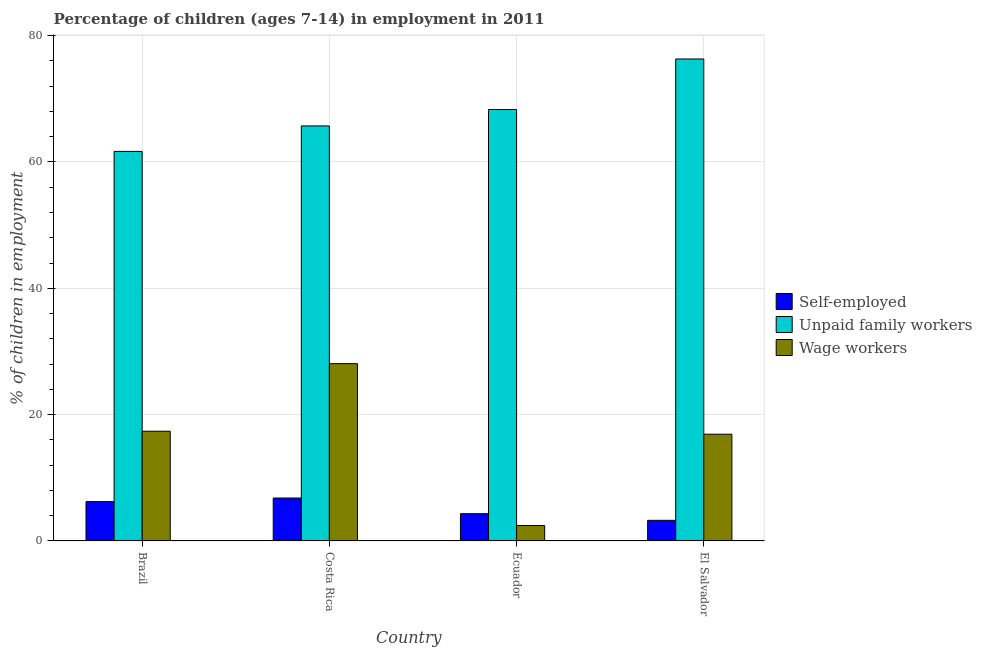How many different coloured bars are there?
Provide a short and direct response. 3. How many bars are there on the 1st tick from the left?
Give a very brief answer. 3. How many bars are there on the 2nd tick from the right?
Your answer should be compact. 3. What is the label of the 4th group of bars from the left?
Keep it short and to the point. El Salvador. In how many cases, is the number of bars for a given country not equal to the number of legend labels?
Give a very brief answer. 0. What is the percentage of children employed as unpaid family workers in Brazil?
Offer a very short reply. 61.67. Across all countries, what is the maximum percentage of children employed as unpaid family workers?
Your response must be concise. 76.3. Across all countries, what is the minimum percentage of children employed as unpaid family workers?
Your answer should be compact. 61.67. In which country was the percentage of children employed as wage workers maximum?
Give a very brief answer. Costa Rica. In which country was the percentage of children employed as unpaid family workers minimum?
Keep it short and to the point. Brazil. What is the total percentage of children employed as wage workers in the graph?
Your response must be concise. 64.79. What is the difference between the percentage of children employed as unpaid family workers in Brazil and that in Ecuador?
Your response must be concise. -6.63. What is the difference between the percentage of self employed children in Brazil and the percentage of children employed as unpaid family workers in Costa Rica?
Make the answer very short. -59.47. What is the average percentage of self employed children per country?
Your answer should be compact. 5.16. What is the difference between the percentage of self employed children and percentage of children employed as wage workers in Brazil?
Provide a succinct answer. -11.14. In how many countries, is the percentage of self employed children greater than 32 %?
Offer a very short reply. 0. What is the ratio of the percentage of self employed children in Brazil to that in Costa Rica?
Provide a short and direct response. 0.92. Is the difference between the percentage of self employed children in Costa Rica and Ecuador greater than the difference between the percentage of children employed as unpaid family workers in Costa Rica and Ecuador?
Provide a succinct answer. Yes. What is the difference between the highest and the lowest percentage of children employed as wage workers?
Your answer should be very brief. 25.62. In how many countries, is the percentage of children employed as wage workers greater than the average percentage of children employed as wage workers taken over all countries?
Offer a very short reply. 3. Is the sum of the percentage of self employed children in Costa Rica and Ecuador greater than the maximum percentage of children employed as wage workers across all countries?
Provide a succinct answer. No. What does the 2nd bar from the left in Ecuador represents?
Give a very brief answer. Unpaid family workers. What does the 1st bar from the right in Costa Rica represents?
Give a very brief answer. Wage workers. How many legend labels are there?
Offer a terse response. 3. How are the legend labels stacked?
Give a very brief answer. Vertical. What is the title of the graph?
Make the answer very short. Percentage of children (ages 7-14) in employment in 2011. Does "Argument" appear as one of the legend labels in the graph?
Make the answer very short. No. What is the label or title of the X-axis?
Ensure brevity in your answer.  Country. What is the label or title of the Y-axis?
Provide a succinct answer. % of children in employment. What is the % of children in employment of Self-employed in Brazil?
Ensure brevity in your answer.  6.23. What is the % of children in employment of Unpaid family workers in Brazil?
Offer a terse response. 61.67. What is the % of children in employment of Wage workers in Brazil?
Offer a terse response. 17.37. What is the % of children in employment of Self-employed in Costa Rica?
Your answer should be very brief. 6.8. What is the % of children in employment of Unpaid family workers in Costa Rica?
Offer a very short reply. 65.7. What is the % of children in employment of Wage workers in Costa Rica?
Provide a succinct answer. 28.07. What is the % of children in employment in Self-employed in Ecuador?
Keep it short and to the point. 4.32. What is the % of children in employment of Unpaid family workers in Ecuador?
Keep it short and to the point. 68.3. What is the % of children in employment in Wage workers in Ecuador?
Make the answer very short. 2.45. What is the % of children in employment of Self-employed in El Salvador?
Provide a short and direct response. 3.27. What is the % of children in employment in Unpaid family workers in El Salvador?
Offer a terse response. 76.3. What is the % of children in employment of Wage workers in El Salvador?
Provide a succinct answer. 16.9. Across all countries, what is the maximum % of children in employment of Unpaid family workers?
Your answer should be very brief. 76.3. Across all countries, what is the maximum % of children in employment of Wage workers?
Keep it short and to the point. 28.07. Across all countries, what is the minimum % of children in employment of Self-employed?
Offer a terse response. 3.27. Across all countries, what is the minimum % of children in employment in Unpaid family workers?
Your answer should be very brief. 61.67. Across all countries, what is the minimum % of children in employment of Wage workers?
Offer a very short reply. 2.45. What is the total % of children in employment of Self-employed in the graph?
Your response must be concise. 20.62. What is the total % of children in employment of Unpaid family workers in the graph?
Ensure brevity in your answer.  271.97. What is the total % of children in employment in Wage workers in the graph?
Your answer should be very brief. 64.79. What is the difference between the % of children in employment of Self-employed in Brazil and that in Costa Rica?
Provide a short and direct response. -0.57. What is the difference between the % of children in employment of Unpaid family workers in Brazil and that in Costa Rica?
Ensure brevity in your answer.  -4.03. What is the difference between the % of children in employment in Wage workers in Brazil and that in Costa Rica?
Provide a short and direct response. -10.7. What is the difference between the % of children in employment of Self-employed in Brazil and that in Ecuador?
Provide a succinct answer. 1.91. What is the difference between the % of children in employment in Unpaid family workers in Brazil and that in Ecuador?
Offer a terse response. -6.63. What is the difference between the % of children in employment in Wage workers in Brazil and that in Ecuador?
Your response must be concise. 14.92. What is the difference between the % of children in employment of Self-employed in Brazil and that in El Salvador?
Offer a very short reply. 2.96. What is the difference between the % of children in employment of Unpaid family workers in Brazil and that in El Salvador?
Provide a short and direct response. -14.63. What is the difference between the % of children in employment of Wage workers in Brazil and that in El Salvador?
Provide a succinct answer. 0.47. What is the difference between the % of children in employment of Self-employed in Costa Rica and that in Ecuador?
Offer a terse response. 2.48. What is the difference between the % of children in employment of Wage workers in Costa Rica and that in Ecuador?
Make the answer very short. 25.62. What is the difference between the % of children in employment in Self-employed in Costa Rica and that in El Salvador?
Offer a terse response. 3.53. What is the difference between the % of children in employment of Unpaid family workers in Costa Rica and that in El Salvador?
Make the answer very short. -10.6. What is the difference between the % of children in employment of Wage workers in Costa Rica and that in El Salvador?
Offer a terse response. 11.17. What is the difference between the % of children in employment in Self-employed in Ecuador and that in El Salvador?
Offer a very short reply. 1.05. What is the difference between the % of children in employment of Unpaid family workers in Ecuador and that in El Salvador?
Offer a very short reply. -8. What is the difference between the % of children in employment of Wage workers in Ecuador and that in El Salvador?
Keep it short and to the point. -14.45. What is the difference between the % of children in employment of Self-employed in Brazil and the % of children in employment of Unpaid family workers in Costa Rica?
Your answer should be very brief. -59.47. What is the difference between the % of children in employment in Self-employed in Brazil and the % of children in employment in Wage workers in Costa Rica?
Give a very brief answer. -21.84. What is the difference between the % of children in employment of Unpaid family workers in Brazil and the % of children in employment of Wage workers in Costa Rica?
Give a very brief answer. 33.6. What is the difference between the % of children in employment in Self-employed in Brazil and the % of children in employment in Unpaid family workers in Ecuador?
Your answer should be compact. -62.07. What is the difference between the % of children in employment in Self-employed in Brazil and the % of children in employment in Wage workers in Ecuador?
Provide a short and direct response. 3.78. What is the difference between the % of children in employment of Unpaid family workers in Brazil and the % of children in employment of Wage workers in Ecuador?
Your response must be concise. 59.22. What is the difference between the % of children in employment in Self-employed in Brazil and the % of children in employment in Unpaid family workers in El Salvador?
Your response must be concise. -70.07. What is the difference between the % of children in employment of Self-employed in Brazil and the % of children in employment of Wage workers in El Salvador?
Give a very brief answer. -10.67. What is the difference between the % of children in employment of Unpaid family workers in Brazil and the % of children in employment of Wage workers in El Salvador?
Provide a short and direct response. 44.77. What is the difference between the % of children in employment of Self-employed in Costa Rica and the % of children in employment of Unpaid family workers in Ecuador?
Your answer should be very brief. -61.5. What is the difference between the % of children in employment in Self-employed in Costa Rica and the % of children in employment in Wage workers in Ecuador?
Your answer should be compact. 4.35. What is the difference between the % of children in employment of Unpaid family workers in Costa Rica and the % of children in employment of Wage workers in Ecuador?
Provide a succinct answer. 63.25. What is the difference between the % of children in employment in Self-employed in Costa Rica and the % of children in employment in Unpaid family workers in El Salvador?
Provide a succinct answer. -69.5. What is the difference between the % of children in employment in Unpaid family workers in Costa Rica and the % of children in employment in Wage workers in El Salvador?
Give a very brief answer. 48.8. What is the difference between the % of children in employment of Self-employed in Ecuador and the % of children in employment of Unpaid family workers in El Salvador?
Ensure brevity in your answer.  -71.98. What is the difference between the % of children in employment of Self-employed in Ecuador and the % of children in employment of Wage workers in El Salvador?
Offer a terse response. -12.58. What is the difference between the % of children in employment in Unpaid family workers in Ecuador and the % of children in employment in Wage workers in El Salvador?
Your response must be concise. 51.4. What is the average % of children in employment in Self-employed per country?
Make the answer very short. 5.16. What is the average % of children in employment of Unpaid family workers per country?
Make the answer very short. 67.99. What is the average % of children in employment in Wage workers per country?
Make the answer very short. 16.2. What is the difference between the % of children in employment of Self-employed and % of children in employment of Unpaid family workers in Brazil?
Your response must be concise. -55.44. What is the difference between the % of children in employment of Self-employed and % of children in employment of Wage workers in Brazil?
Ensure brevity in your answer.  -11.14. What is the difference between the % of children in employment of Unpaid family workers and % of children in employment of Wage workers in Brazil?
Ensure brevity in your answer.  44.3. What is the difference between the % of children in employment in Self-employed and % of children in employment in Unpaid family workers in Costa Rica?
Keep it short and to the point. -58.9. What is the difference between the % of children in employment of Self-employed and % of children in employment of Wage workers in Costa Rica?
Provide a short and direct response. -21.27. What is the difference between the % of children in employment in Unpaid family workers and % of children in employment in Wage workers in Costa Rica?
Provide a short and direct response. 37.63. What is the difference between the % of children in employment of Self-employed and % of children in employment of Unpaid family workers in Ecuador?
Give a very brief answer. -63.98. What is the difference between the % of children in employment in Self-employed and % of children in employment in Wage workers in Ecuador?
Make the answer very short. 1.87. What is the difference between the % of children in employment of Unpaid family workers and % of children in employment of Wage workers in Ecuador?
Keep it short and to the point. 65.85. What is the difference between the % of children in employment of Self-employed and % of children in employment of Unpaid family workers in El Salvador?
Ensure brevity in your answer.  -73.03. What is the difference between the % of children in employment of Self-employed and % of children in employment of Wage workers in El Salvador?
Your answer should be compact. -13.63. What is the difference between the % of children in employment of Unpaid family workers and % of children in employment of Wage workers in El Salvador?
Ensure brevity in your answer.  59.4. What is the ratio of the % of children in employment of Self-employed in Brazil to that in Costa Rica?
Make the answer very short. 0.92. What is the ratio of the % of children in employment in Unpaid family workers in Brazil to that in Costa Rica?
Make the answer very short. 0.94. What is the ratio of the % of children in employment in Wage workers in Brazil to that in Costa Rica?
Provide a succinct answer. 0.62. What is the ratio of the % of children in employment in Self-employed in Brazil to that in Ecuador?
Keep it short and to the point. 1.44. What is the ratio of the % of children in employment in Unpaid family workers in Brazil to that in Ecuador?
Provide a short and direct response. 0.9. What is the ratio of the % of children in employment of Wage workers in Brazil to that in Ecuador?
Keep it short and to the point. 7.09. What is the ratio of the % of children in employment in Self-employed in Brazil to that in El Salvador?
Give a very brief answer. 1.91. What is the ratio of the % of children in employment of Unpaid family workers in Brazil to that in El Salvador?
Provide a short and direct response. 0.81. What is the ratio of the % of children in employment in Wage workers in Brazil to that in El Salvador?
Offer a very short reply. 1.03. What is the ratio of the % of children in employment of Self-employed in Costa Rica to that in Ecuador?
Offer a very short reply. 1.57. What is the ratio of the % of children in employment of Unpaid family workers in Costa Rica to that in Ecuador?
Ensure brevity in your answer.  0.96. What is the ratio of the % of children in employment of Wage workers in Costa Rica to that in Ecuador?
Offer a terse response. 11.46. What is the ratio of the % of children in employment of Self-employed in Costa Rica to that in El Salvador?
Your response must be concise. 2.08. What is the ratio of the % of children in employment in Unpaid family workers in Costa Rica to that in El Salvador?
Your answer should be very brief. 0.86. What is the ratio of the % of children in employment in Wage workers in Costa Rica to that in El Salvador?
Your response must be concise. 1.66. What is the ratio of the % of children in employment in Self-employed in Ecuador to that in El Salvador?
Ensure brevity in your answer.  1.32. What is the ratio of the % of children in employment in Unpaid family workers in Ecuador to that in El Salvador?
Ensure brevity in your answer.  0.9. What is the ratio of the % of children in employment of Wage workers in Ecuador to that in El Salvador?
Make the answer very short. 0.14. What is the difference between the highest and the second highest % of children in employment in Self-employed?
Make the answer very short. 0.57. What is the difference between the highest and the lowest % of children in employment of Self-employed?
Offer a terse response. 3.53. What is the difference between the highest and the lowest % of children in employment in Unpaid family workers?
Make the answer very short. 14.63. What is the difference between the highest and the lowest % of children in employment in Wage workers?
Ensure brevity in your answer.  25.62. 